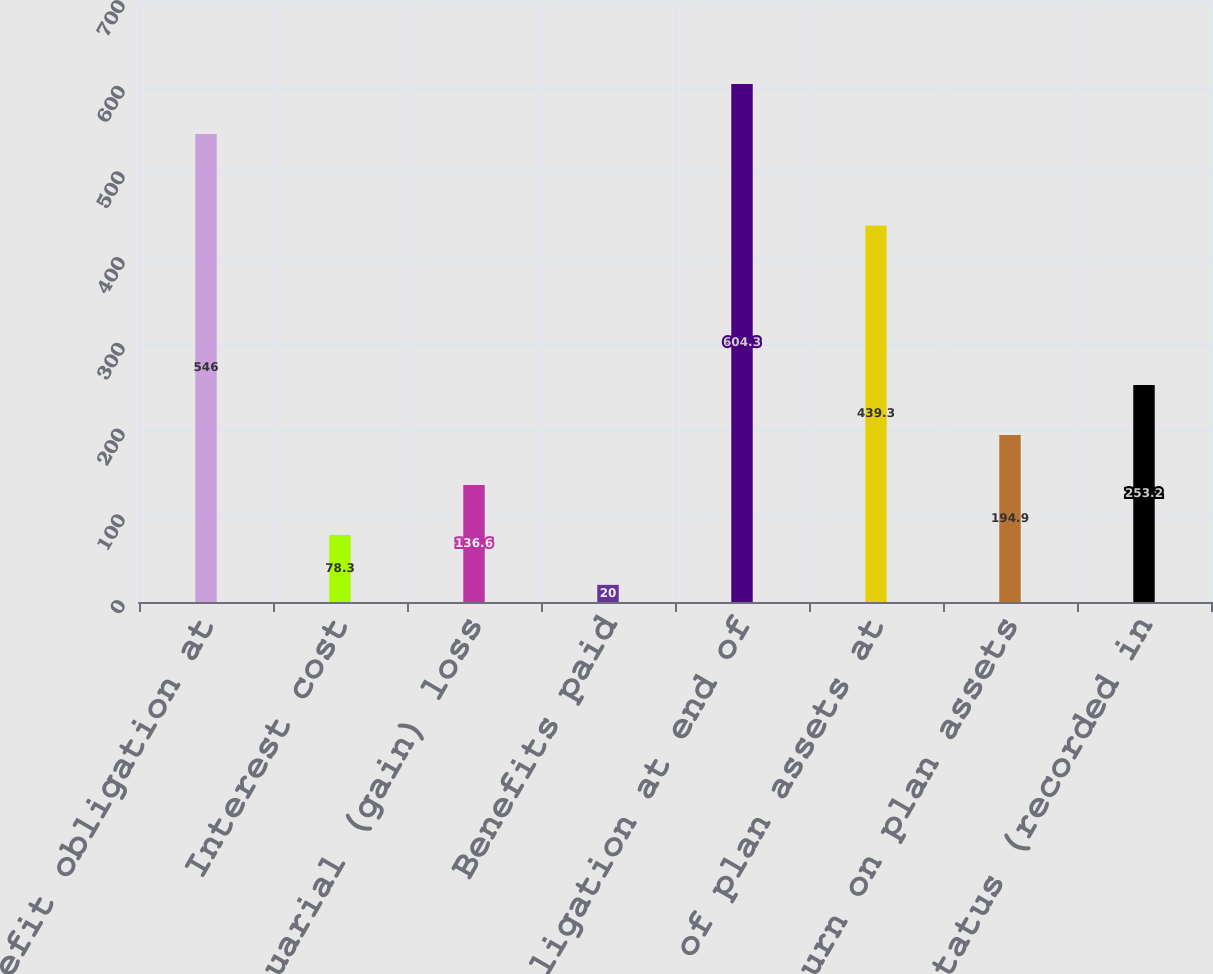Convert chart. <chart><loc_0><loc_0><loc_500><loc_500><bar_chart><fcel>Benefit obligation at<fcel>Interest cost<fcel>Actuarial (gain) loss<fcel>Benefits paid<fcel>Benefit obligation at end of<fcel>Fair value of plan assets at<fcel>Actual return on plan assets<fcel>Unfunded status (recorded in<nl><fcel>546<fcel>78.3<fcel>136.6<fcel>20<fcel>604.3<fcel>439.3<fcel>194.9<fcel>253.2<nl></chart> 